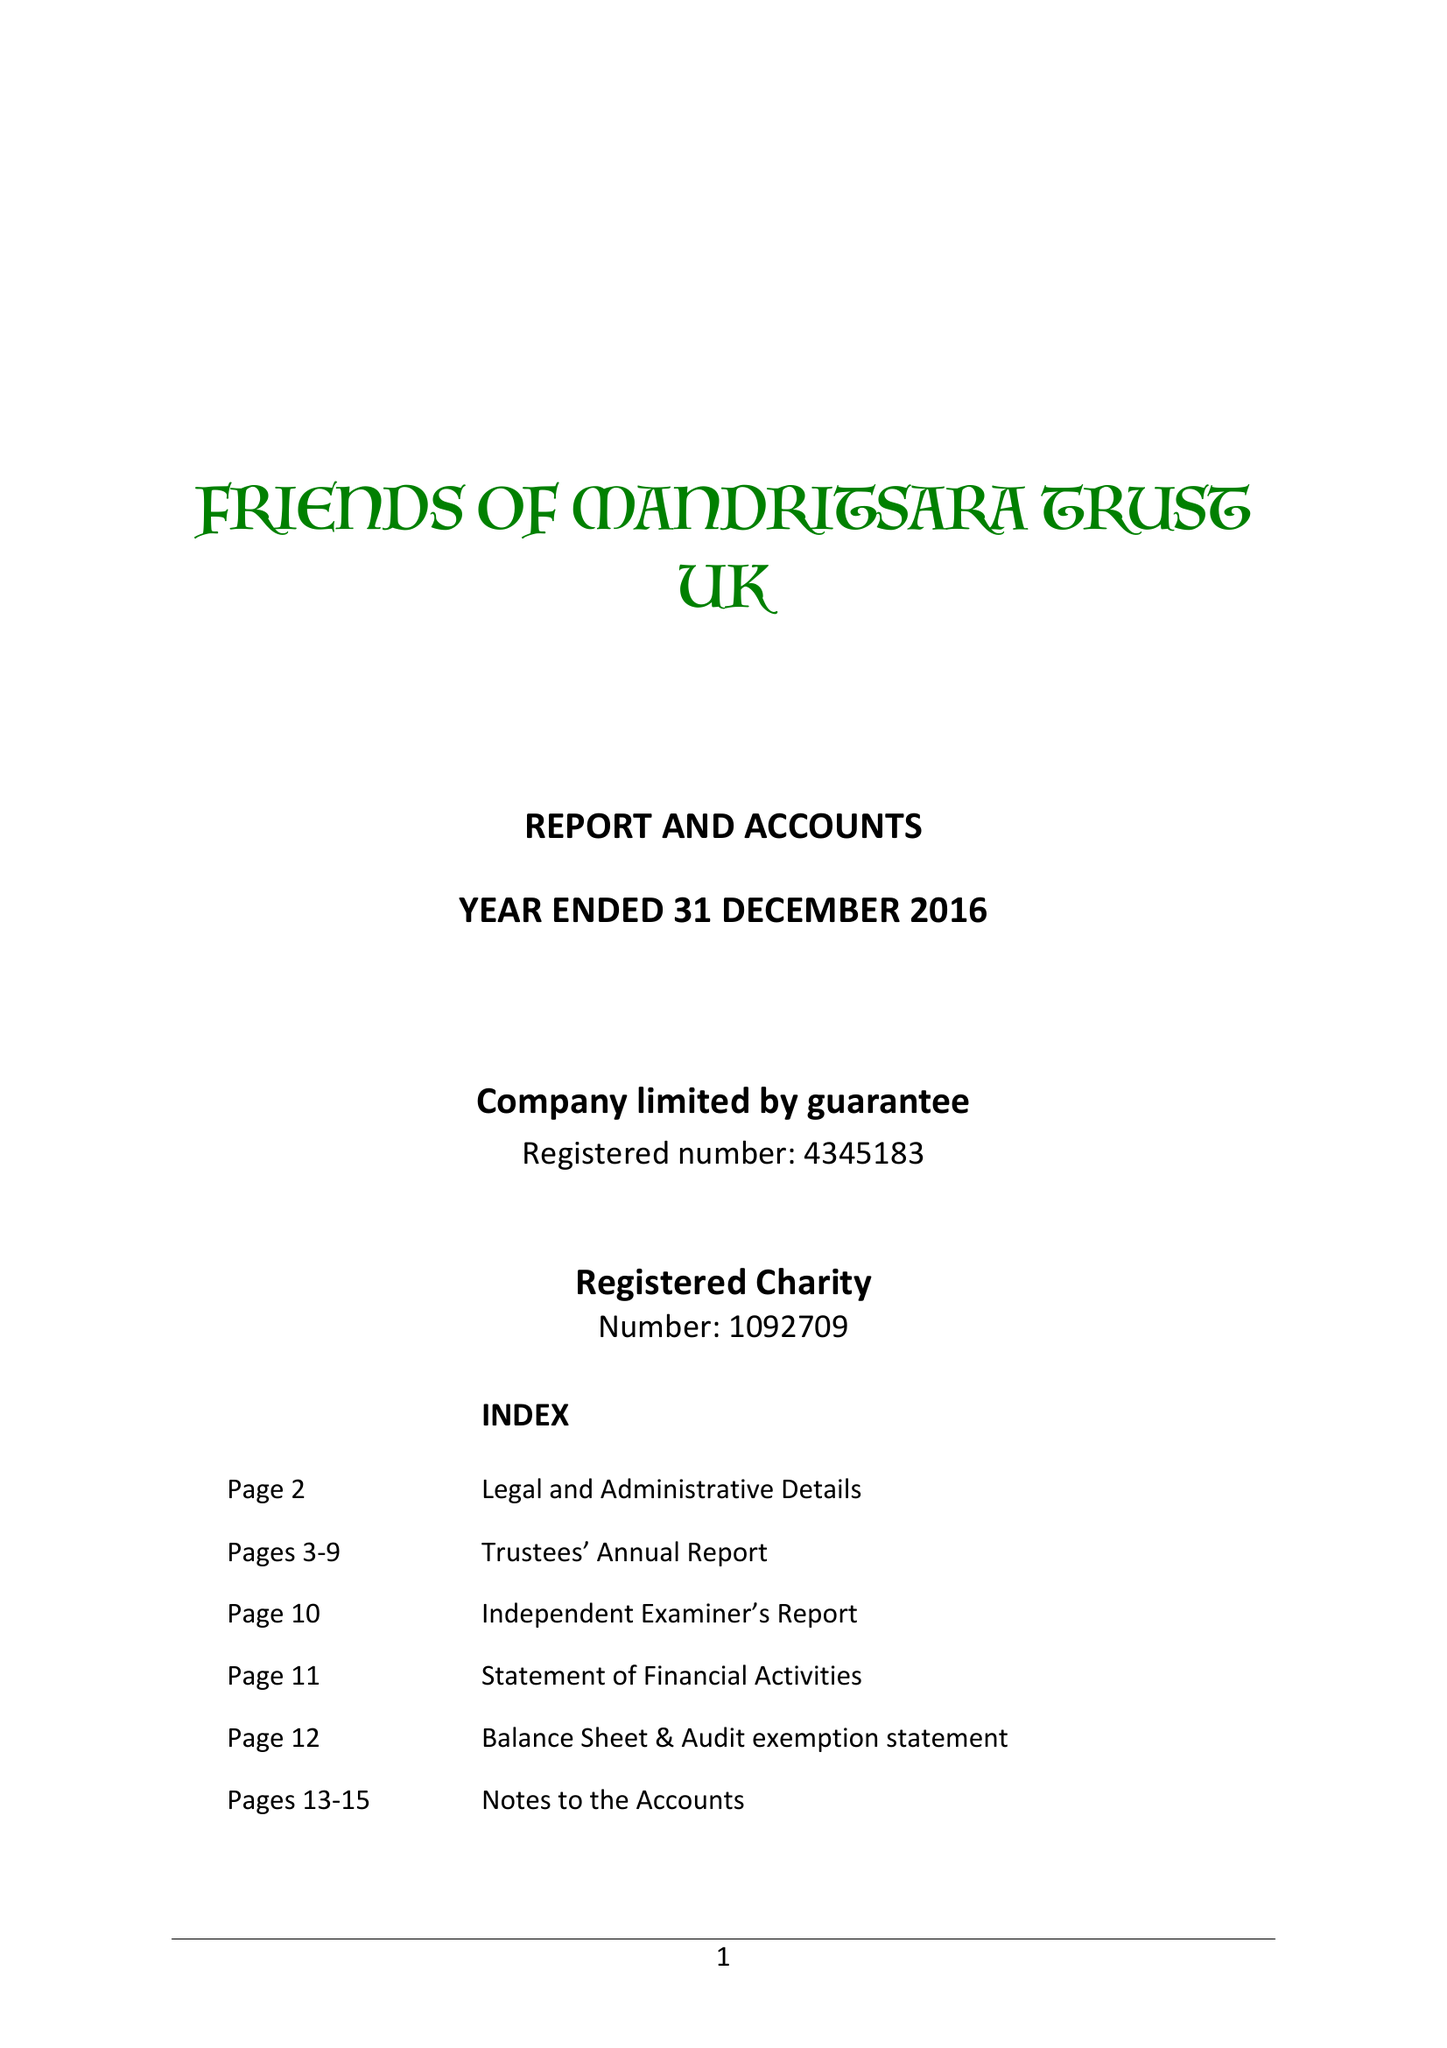What is the value for the charity_number?
Answer the question using a single word or phrase. 1092709 